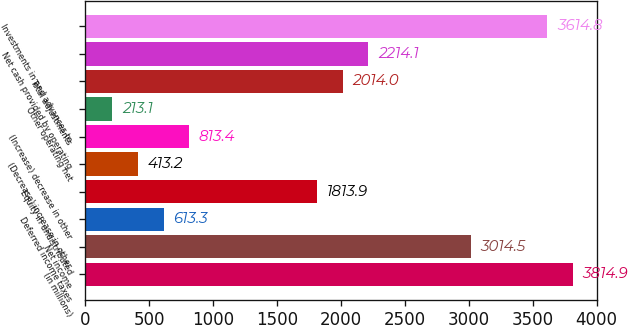<chart> <loc_0><loc_0><loc_500><loc_500><bar_chart><fcel>(in millions)<fcel>Net income<fcel>Deferred income taxes<fcel>Equity in undistributed<fcel>(Decrease) increase in other<fcel>(Increase) decrease in other<fcel>Other operating net<fcel>Total adjustments<fcel>Net cash provided by operating<fcel>Investments in and advances to<nl><fcel>3814.9<fcel>3014.5<fcel>613.3<fcel>1813.9<fcel>413.2<fcel>813.4<fcel>213.1<fcel>2014<fcel>2214.1<fcel>3614.8<nl></chart> 